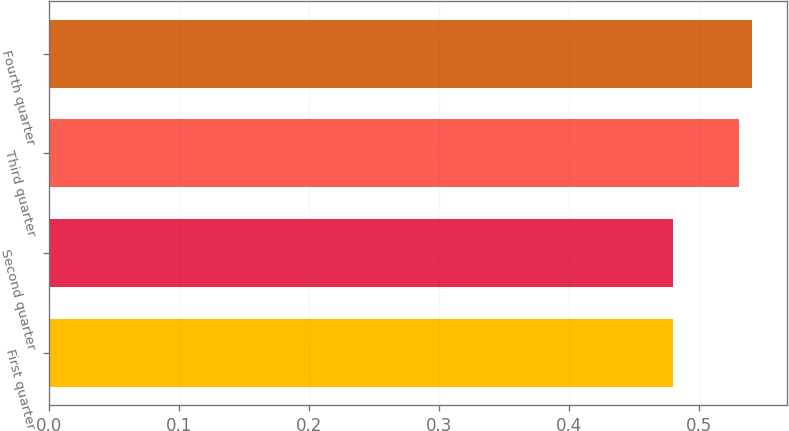Convert chart to OTSL. <chart><loc_0><loc_0><loc_500><loc_500><bar_chart><fcel>First quarter<fcel>Second quarter<fcel>Third quarter<fcel>Fourth quarter<nl><fcel>0.48<fcel>0.48<fcel>0.53<fcel>0.54<nl></chart> 